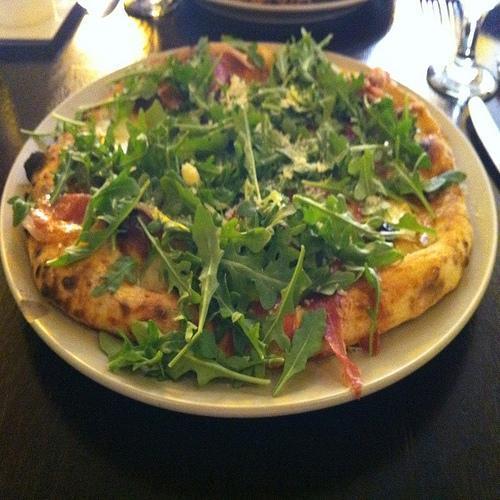How many plates are shown?
Give a very brief answer. 1. 